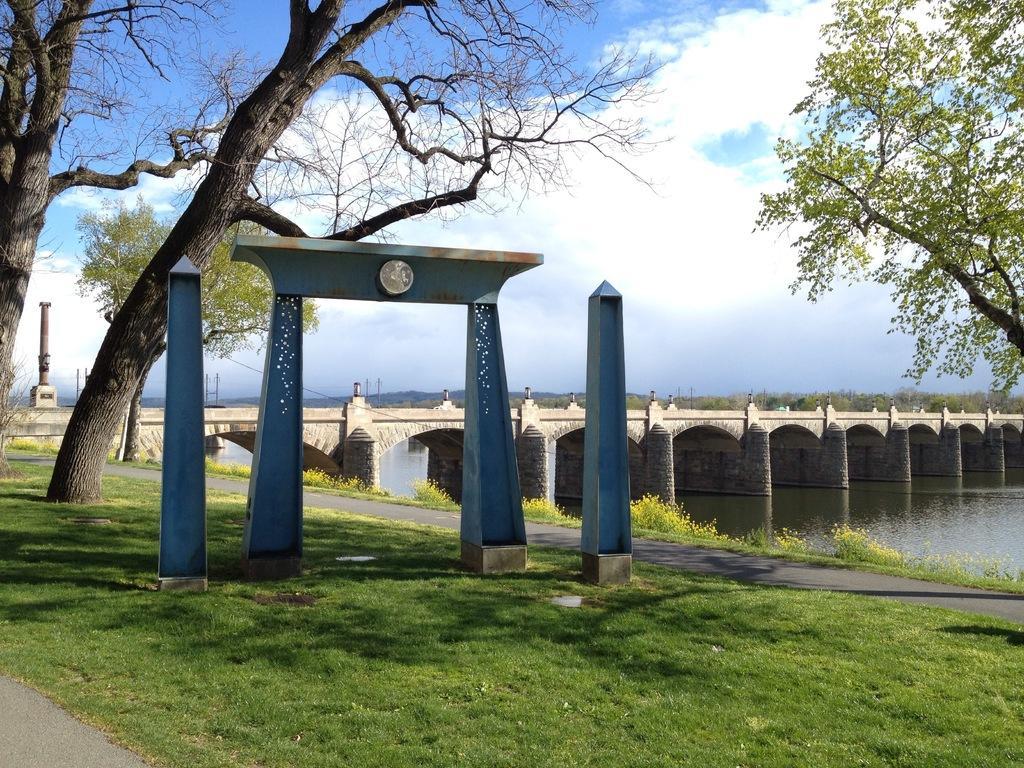Please provide a concise description of this image. In this picture we can see poles, arch on the ground, here we can see a bridge, trees, under this bridge we can see water and we can see sky in the background. 